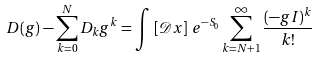Convert formula to latex. <formula><loc_0><loc_0><loc_500><loc_500>D ( g ) - \sum _ { k = 0 } ^ { N } D _ { k } g ^ { k } = \int \, \left [ \mathcal { D } x \right ] \, e ^ { - S _ { 0 } } \sum _ { k = N + 1 } ^ { \infty } \frac { ( - g I ) ^ { k } } { k ! }</formula> 